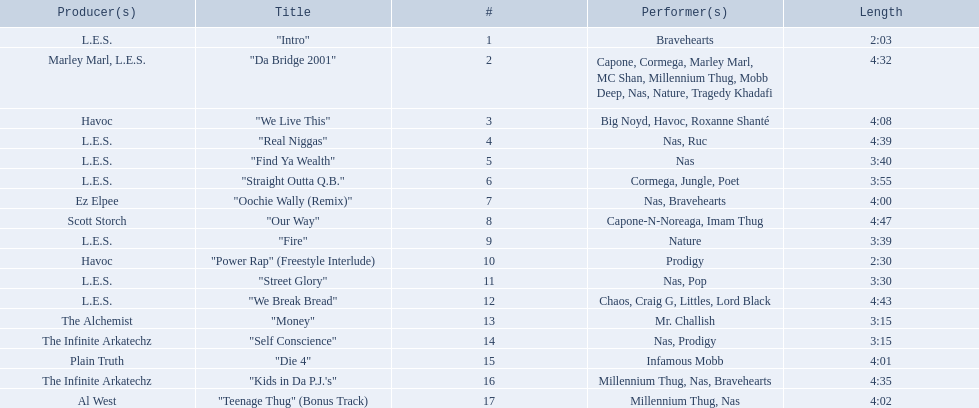What are all the songs on the album? "Intro", "Da Bridge 2001", "We Live This", "Real Niggas", "Find Ya Wealth", "Straight Outta Q.B.", "Oochie Wally (Remix)", "Our Way", "Fire", "Power Rap" (Freestyle Interlude), "Street Glory", "We Break Bread", "Money", "Self Conscience", "Die 4", "Kids in Da P.J.'s", "Teenage Thug" (Bonus Track). Which is the shortest? "Intro". How long is that song? 2:03. 